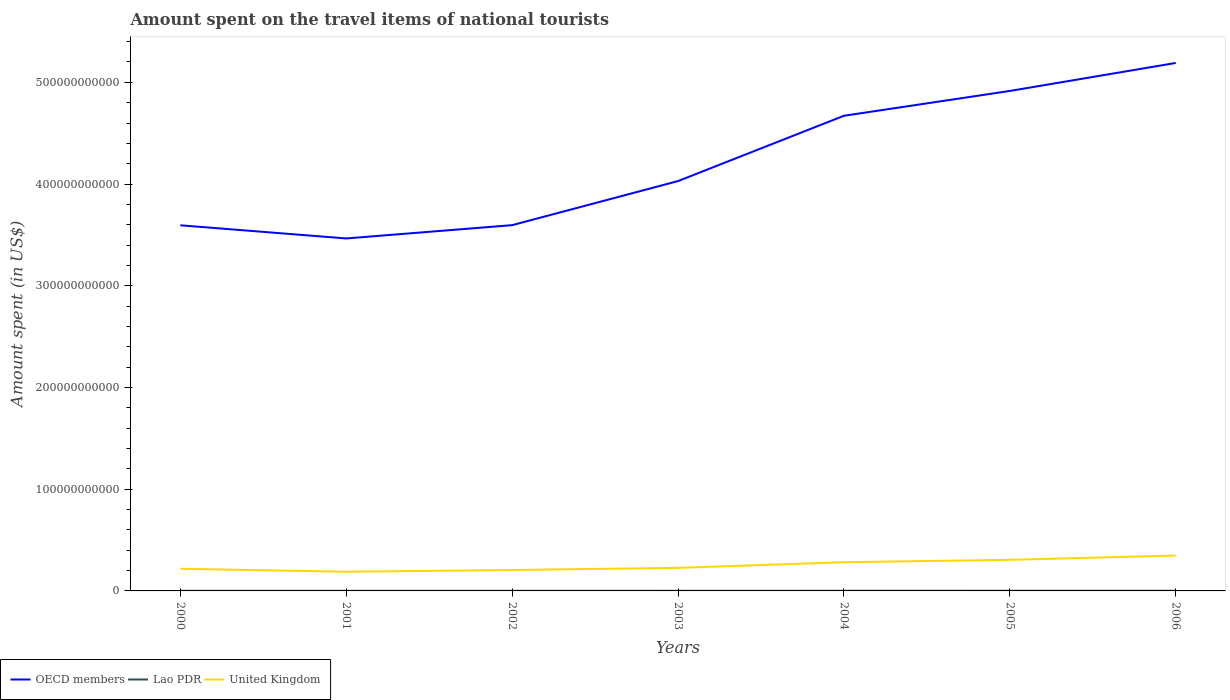Across all years, what is the maximum amount spent on the travel items of national tourists in OECD members?
Keep it short and to the point. 3.47e+11. In which year was the amount spent on the travel items of national tourists in OECD members maximum?
Offer a very short reply. 2001. What is the total amount spent on the travel items of national tourists in Lao PDR in the graph?
Your response must be concise. 7.00e+06. What is the difference between the highest and the second highest amount spent on the travel items of national tourists in Lao PDR?
Provide a succinct answer. 8.40e+07. What is the difference between the highest and the lowest amount spent on the travel items of national tourists in United Kingdom?
Your response must be concise. 3. How many lines are there?
Provide a succinct answer. 3. What is the difference between two consecutive major ticks on the Y-axis?
Keep it short and to the point. 1.00e+11. Does the graph contain any zero values?
Give a very brief answer. No. Does the graph contain grids?
Make the answer very short. No. Where does the legend appear in the graph?
Make the answer very short. Bottom left. How are the legend labels stacked?
Offer a terse response. Horizontal. What is the title of the graph?
Your answer should be very brief. Amount spent on the travel items of national tourists. What is the label or title of the X-axis?
Your response must be concise. Years. What is the label or title of the Y-axis?
Your response must be concise. Amount spent (in US$). What is the Amount spent (in US$) of OECD members in 2000?
Your answer should be compact. 3.59e+11. What is the Amount spent (in US$) of Lao PDR in 2000?
Provide a short and direct response. 1.14e+08. What is the Amount spent (in US$) in United Kingdom in 2000?
Give a very brief answer. 2.18e+1. What is the Amount spent (in US$) of OECD members in 2001?
Your response must be concise. 3.47e+11. What is the Amount spent (in US$) in Lao PDR in 2001?
Offer a very short reply. 1.04e+08. What is the Amount spent (in US$) of United Kingdom in 2001?
Offer a very short reply. 1.89e+1. What is the Amount spent (in US$) in OECD members in 2002?
Keep it short and to the point. 3.60e+11. What is the Amount spent (in US$) in Lao PDR in 2002?
Ensure brevity in your answer.  1.07e+08. What is the Amount spent (in US$) in United Kingdom in 2002?
Keep it short and to the point. 2.05e+1. What is the Amount spent (in US$) in OECD members in 2003?
Offer a terse response. 4.03e+11. What is the Amount spent (in US$) in Lao PDR in 2003?
Make the answer very short. 7.40e+07. What is the Amount spent (in US$) of United Kingdom in 2003?
Ensure brevity in your answer.  2.27e+1. What is the Amount spent (in US$) of OECD members in 2004?
Provide a short and direct response. 4.67e+11. What is the Amount spent (in US$) in Lao PDR in 2004?
Your answer should be compact. 1.19e+08. What is the Amount spent (in US$) in United Kingdom in 2004?
Provide a short and direct response. 2.82e+1. What is the Amount spent (in US$) of OECD members in 2005?
Keep it short and to the point. 4.92e+11. What is the Amount spent (in US$) in Lao PDR in 2005?
Your answer should be very brief. 1.39e+08. What is the Amount spent (in US$) of United Kingdom in 2005?
Offer a terse response. 3.06e+1. What is the Amount spent (in US$) of OECD members in 2006?
Ensure brevity in your answer.  5.19e+11. What is the Amount spent (in US$) of Lao PDR in 2006?
Give a very brief answer. 1.58e+08. What is the Amount spent (in US$) of United Kingdom in 2006?
Offer a very short reply. 3.48e+1. Across all years, what is the maximum Amount spent (in US$) in OECD members?
Your answer should be compact. 5.19e+11. Across all years, what is the maximum Amount spent (in US$) in Lao PDR?
Make the answer very short. 1.58e+08. Across all years, what is the maximum Amount spent (in US$) in United Kingdom?
Your answer should be very brief. 3.48e+1. Across all years, what is the minimum Amount spent (in US$) of OECD members?
Your answer should be very brief. 3.47e+11. Across all years, what is the minimum Amount spent (in US$) of Lao PDR?
Give a very brief answer. 7.40e+07. Across all years, what is the minimum Amount spent (in US$) of United Kingdom?
Offer a terse response. 1.89e+1. What is the total Amount spent (in US$) of OECD members in the graph?
Provide a short and direct response. 2.95e+12. What is the total Amount spent (in US$) in Lao PDR in the graph?
Keep it short and to the point. 8.15e+08. What is the total Amount spent (in US$) of United Kingdom in the graph?
Keep it short and to the point. 1.77e+11. What is the difference between the Amount spent (in US$) of OECD members in 2000 and that in 2001?
Ensure brevity in your answer.  1.29e+1. What is the difference between the Amount spent (in US$) in Lao PDR in 2000 and that in 2001?
Your answer should be compact. 1.00e+07. What is the difference between the Amount spent (in US$) of United Kingdom in 2000 and that in 2001?
Ensure brevity in your answer.  2.90e+09. What is the difference between the Amount spent (in US$) of OECD members in 2000 and that in 2002?
Keep it short and to the point. -1.32e+08. What is the difference between the Amount spent (in US$) of United Kingdom in 2000 and that in 2002?
Keep it short and to the point. 1.22e+09. What is the difference between the Amount spent (in US$) of OECD members in 2000 and that in 2003?
Offer a terse response. -4.35e+1. What is the difference between the Amount spent (in US$) in Lao PDR in 2000 and that in 2003?
Your response must be concise. 4.00e+07. What is the difference between the Amount spent (in US$) of United Kingdom in 2000 and that in 2003?
Your answer should be compact. -8.99e+08. What is the difference between the Amount spent (in US$) of OECD members in 2000 and that in 2004?
Offer a terse response. -1.08e+11. What is the difference between the Amount spent (in US$) in Lao PDR in 2000 and that in 2004?
Give a very brief answer. -5.00e+06. What is the difference between the Amount spent (in US$) of United Kingdom in 2000 and that in 2004?
Give a very brief answer. -6.43e+09. What is the difference between the Amount spent (in US$) in OECD members in 2000 and that in 2005?
Offer a terse response. -1.32e+11. What is the difference between the Amount spent (in US$) in Lao PDR in 2000 and that in 2005?
Offer a very short reply. -2.50e+07. What is the difference between the Amount spent (in US$) in United Kingdom in 2000 and that in 2005?
Your answer should be compact. -8.80e+09. What is the difference between the Amount spent (in US$) in OECD members in 2000 and that in 2006?
Offer a very short reply. -1.60e+11. What is the difference between the Amount spent (in US$) in Lao PDR in 2000 and that in 2006?
Your answer should be compact. -4.40e+07. What is the difference between the Amount spent (in US$) in United Kingdom in 2000 and that in 2006?
Keep it short and to the point. -1.30e+1. What is the difference between the Amount spent (in US$) of OECD members in 2001 and that in 2002?
Provide a succinct answer. -1.31e+1. What is the difference between the Amount spent (in US$) in United Kingdom in 2001 and that in 2002?
Make the answer very short. -1.68e+09. What is the difference between the Amount spent (in US$) in OECD members in 2001 and that in 2003?
Ensure brevity in your answer.  -5.64e+1. What is the difference between the Amount spent (in US$) of Lao PDR in 2001 and that in 2003?
Your response must be concise. 3.00e+07. What is the difference between the Amount spent (in US$) in United Kingdom in 2001 and that in 2003?
Make the answer very short. -3.80e+09. What is the difference between the Amount spent (in US$) of OECD members in 2001 and that in 2004?
Make the answer very short. -1.21e+11. What is the difference between the Amount spent (in US$) in Lao PDR in 2001 and that in 2004?
Provide a short and direct response. -1.50e+07. What is the difference between the Amount spent (in US$) in United Kingdom in 2001 and that in 2004?
Provide a short and direct response. -9.34e+09. What is the difference between the Amount spent (in US$) in OECD members in 2001 and that in 2005?
Give a very brief answer. -1.45e+11. What is the difference between the Amount spent (in US$) in Lao PDR in 2001 and that in 2005?
Your answer should be very brief. -3.50e+07. What is the difference between the Amount spent (in US$) of United Kingdom in 2001 and that in 2005?
Provide a short and direct response. -1.17e+1. What is the difference between the Amount spent (in US$) of OECD members in 2001 and that in 2006?
Your answer should be compact. -1.73e+11. What is the difference between the Amount spent (in US$) of Lao PDR in 2001 and that in 2006?
Keep it short and to the point. -5.40e+07. What is the difference between the Amount spent (in US$) of United Kingdom in 2001 and that in 2006?
Keep it short and to the point. -1.59e+1. What is the difference between the Amount spent (in US$) of OECD members in 2002 and that in 2003?
Offer a very short reply. -4.33e+1. What is the difference between the Amount spent (in US$) of Lao PDR in 2002 and that in 2003?
Make the answer very short. 3.30e+07. What is the difference between the Amount spent (in US$) of United Kingdom in 2002 and that in 2003?
Keep it short and to the point. -2.12e+09. What is the difference between the Amount spent (in US$) in OECD members in 2002 and that in 2004?
Offer a very short reply. -1.08e+11. What is the difference between the Amount spent (in US$) of Lao PDR in 2002 and that in 2004?
Offer a very short reply. -1.20e+07. What is the difference between the Amount spent (in US$) in United Kingdom in 2002 and that in 2004?
Make the answer very short. -7.65e+09. What is the difference between the Amount spent (in US$) in OECD members in 2002 and that in 2005?
Your answer should be very brief. -1.32e+11. What is the difference between the Amount spent (in US$) in Lao PDR in 2002 and that in 2005?
Your answer should be very brief. -3.20e+07. What is the difference between the Amount spent (in US$) in United Kingdom in 2002 and that in 2005?
Offer a very short reply. -1.00e+1. What is the difference between the Amount spent (in US$) of OECD members in 2002 and that in 2006?
Your answer should be compact. -1.59e+11. What is the difference between the Amount spent (in US$) of Lao PDR in 2002 and that in 2006?
Provide a succinct answer. -5.10e+07. What is the difference between the Amount spent (in US$) of United Kingdom in 2002 and that in 2006?
Keep it short and to the point. -1.42e+1. What is the difference between the Amount spent (in US$) of OECD members in 2003 and that in 2004?
Keep it short and to the point. -6.42e+1. What is the difference between the Amount spent (in US$) in Lao PDR in 2003 and that in 2004?
Make the answer very short. -4.50e+07. What is the difference between the Amount spent (in US$) of United Kingdom in 2003 and that in 2004?
Make the answer very short. -5.53e+09. What is the difference between the Amount spent (in US$) in OECD members in 2003 and that in 2005?
Your response must be concise. -8.86e+1. What is the difference between the Amount spent (in US$) of Lao PDR in 2003 and that in 2005?
Offer a very short reply. -6.50e+07. What is the difference between the Amount spent (in US$) in United Kingdom in 2003 and that in 2005?
Your response must be concise. -7.90e+09. What is the difference between the Amount spent (in US$) of OECD members in 2003 and that in 2006?
Provide a short and direct response. -1.16e+11. What is the difference between the Amount spent (in US$) in Lao PDR in 2003 and that in 2006?
Offer a very short reply. -8.40e+07. What is the difference between the Amount spent (in US$) of United Kingdom in 2003 and that in 2006?
Give a very brief answer. -1.21e+1. What is the difference between the Amount spent (in US$) of OECD members in 2004 and that in 2005?
Make the answer very short. -2.44e+1. What is the difference between the Amount spent (in US$) in Lao PDR in 2004 and that in 2005?
Keep it short and to the point. -2.00e+07. What is the difference between the Amount spent (in US$) of United Kingdom in 2004 and that in 2005?
Keep it short and to the point. -2.37e+09. What is the difference between the Amount spent (in US$) of OECD members in 2004 and that in 2006?
Offer a very short reply. -5.19e+1. What is the difference between the Amount spent (in US$) of Lao PDR in 2004 and that in 2006?
Your answer should be compact. -3.90e+07. What is the difference between the Amount spent (in US$) in United Kingdom in 2004 and that in 2006?
Provide a succinct answer. -6.59e+09. What is the difference between the Amount spent (in US$) in OECD members in 2005 and that in 2006?
Offer a terse response. -2.75e+1. What is the difference between the Amount spent (in US$) of Lao PDR in 2005 and that in 2006?
Provide a short and direct response. -1.90e+07. What is the difference between the Amount spent (in US$) in United Kingdom in 2005 and that in 2006?
Offer a very short reply. -4.22e+09. What is the difference between the Amount spent (in US$) of OECD members in 2000 and the Amount spent (in US$) of Lao PDR in 2001?
Offer a terse response. 3.59e+11. What is the difference between the Amount spent (in US$) in OECD members in 2000 and the Amount spent (in US$) in United Kingdom in 2001?
Your answer should be very brief. 3.41e+11. What is the difference between the Amount spent (in US$) of Lao PDR in 2000 and the Amount spent (in US$) of United Kingdom in 2001?
Your answer should be very brief. -1.88e+1. What is the difference between the Amount spent (in US$) in OECD members in 2000 and the Amount spent (in US$) in Lao PDR in 2002?
Keep it short and to the point. 3.59e+11. What is the difference between the Amount spent (in US$) in OECD members in 2000 and the Amount spent (in US$) in United Kingdom in 2002?
Your response must be concise. 3.39e+11. What is the difference between the Amount spent (in US$) in Lao PDR in 2000 and the Amount spent (in US$) in United Kingdom in 2002?
Keep it short and to the point. -2.04e+1. What is the difference between the Amount spent (in US$) of OECD members in 2000 and the Amount spent (in US$) of Lao PDR in 2003?
Provide a short and direct response. 3.59e+11. What is the difference between the Amount spent (in US$) in OECD members in 2000 and the Amount spent (in US$) in United Kingdom in 2003?
Provide a short and direct response. 3.37e+11. What is the difference between the Amount spent (in US$) in Lao PDR in 2000 and the Amount spent (in US$) in United Kingdom in 2003?
Ensure brevity in your answer.  -2.26e+1. What is the difference between the Amount spent (in US$) in OECD members in 2000 and the Amount spent (in US$) in Lao PDR in 2004?
Your response must be concise. 3.59e+11. What is the difference between the Amount spent (in US$) of OECD members in 2000 and the Amount spent (in US$) of United Kingdom in 2004?
Keep it short and to the point. 3.31e+11. What is the difference between the Amount spent (in US$) in Lao PDR in 2000 and the Amount spent (in US$) in United Kingdom in 2004?
Offer a terse response. -2.81e+1. What is the difference between the Amount spent (in US$) of OECD members in 2000 and the Amount spent (in US$) of Lao PDR in 2005?
Offer a very short reply. 3.59e+11. What is the difference between the Amount spent (in US$) of OECD members in 2000 and the Amount spent (in US$) of United Kingdom in 2005?
Your answer should be very brief. 3.29e+11. What is the difference between the Amount spent (in US$) of Lao PDR in 2000 and the Amount spent (in US$) of United Kingdom in 2005?
Your response must be concise. -3.05e+1. What is the difference between the Amount spent (in US$) of OECD members in 2000 and the Amount spent (in US$) of Lao PDR in 2006?
Your answer should be very brief. 3.59e+11. What is the difference between the Amount spent (in US$) in OECD members in 2000 and the Amount spent (in US$) in United Kingdom in 2006?
Make the answer very short. 3.25e+11. What is the difference between the Amount spent (in US$) of Lao PDR in 2000 and the Amount spent (in US$) of United Kingdom in 2006?
Your answer should be compact. -3.47e+1. What is the difference between the Amount spent (in US$) of OECD members in 2001 and the Amount spent (in US$) of Lao PDR in 2002?
Your answer should be very brief. 3.46e+11. What is the difference between the Amount spent (in US$) in OECD members in 2001 and the Amount spent (in US$) in United Kingdom in 2002?
Offer a terse response. 3.26e+11. What is the difference between the Amount spent (in US$) in Lao PDR in 2001 and the Amount spent (in US$) in United Kingdom in 2002?
Provide a succinct answer. -2.04e+1. What is the difference between the Amount spent (in US$) of OECD members in 2001 and the Amount spent (in US$) of Lao PDR in 2003?
Offer a very short reply. 3.46e+11. What is the difference between the Amount spent (in US$) in OECD members in 2001 and the Amount spent (in US$) in United Kingdom in 2003?
Give a very brief answer. 3.24e+11. What is the difference between the Amount spent (in US$) in Lao PDR in 2001 and the Amount spent (in US$) in United Kingdom in 2003?
Provide a short and direct response. -2.26e+1. What is the difference between the Amount spent (in US$) in OECD members in 2001 and the Amount spent (in US$) in Lao PDR in 2004?
Keep it short and to the point. 3.46e+11. What is the difference between the Amount spent (in US$) of OECD members in 2001 and the Amount spent (in US$) of United Kingdom in 2004?
Offer a terse response. 3.18e+11. What is the difference between the Amount spent (in US$) of Lao PDR in 2001 and the Amount spent (in US$) of United Kingdom in 2004?
Offer a very short reply. -2.81e+1. What is the difference between the Amount spent (in US$) in OECD members in 2001 and the Amount spent (in US$) in Lao PDR in 2005?
Your answer should be compact. 3.46e+11. What is the difference between the Amount spent (in US$) in OECD members in 2001 and the Amount spent (in US$) in United Kingdom in 2005?
Give a very brief answer. 3.16e+11. What is the difference between the Amount spent (in US$) of Lao PDR in 2001 and the Amount spent (in US$) of United Kingdom in 2005?
Ensure brevity in your answer.  -3.05e+1. What is the difference between the Amount spent (in US$) in OECD members in 2001 and the Amount spent (in US$) in Lao PDR in 2006?
Provide a short and direct response. 3.46e+11. What is the difference between the Amount spent (in US$) of OECD members in 2001 and the Amount spent (in US$) of United Kingdom in 2006?
Your answer should be compact. 3.12e+11. What is the difference between the Amount spent (in US$) of Lao PDR in 2001 and the Amount spent (in US$) of United Kingdom in 2006?
Your answer should be very brief. -3.47e+1. What is the difference between the Amount spent (in US$) of OECD members in 2002 and the Amount spent (in US$) of Lao PDR in 2003?
Make the answer very short. 3.60e+11. What is the difference between the Amount spent (in US$) of OECD members in 2002 and the Amount spent (in US$) of United Kingdom in 2003?
Provide a succinct answer. 3.37e+11. What is the difference between the Amount spent (in US$) in Lao PDR in 2002 and the Amount spent (in US$) in United Kingdom in 2003?
Provide a short and direct response. -2.26e+1. What is the difference between the Amount spent (in US$) of OECD members in 2002 and the Amount spent (in US$) of Lao PDR in 2004?
Your answer should be compact. 3.59e+11. What is the difference between the Amount spent (in US$) of OECD members in 2002 and the Amount spent (in US$) of United Kingdom in 2004?
Ensure brevity in your answer.  3.31e+11. What is the difference between the Amount spent (in US$) of Lao PDR in 2002 and the Amount spent (in US$) of United Kingdom in 2004?
Your response must be concise. -2.81e+1. What is the difference between the Amount spent (in US$) in OECD members in 2002 and the Amount spent (in US$) in Lao PDR in 2005?
Make the answer very short. 3.59e+11. What is the difference between the Amount spent (in US$) in OECD members in 2002 and the Amount spent (in US$) in United Kingdom in 2005?
Your answer should be compact. 3.29e+11. What is the difference between the Amount spent (in US$) in Lao PDR in 2002 and the Amount spent (in US$) in United Kingdom in 2005?
Ensure brevity in your answer.  -3.05e+1. What is the difference between the Amount spent (in US$) of OECD members in 2002 and the Amount spent (in US$) of Lao PDR in 2006?
Keep it short and to the point. 3.59e+11. What is the difference between the Amount spent (in US$) of OECD members in 2002 and the Amount spent (in US$) of United Kingdom in 2006?
Offer a terse response. 3.25e+11. What is the difference between the Amount spent (in US$) of Lao PDR in 2002 and the Amount spent (in US$) of United Kingdom in 2006?
Your answer should be very brief. -3.47e+1. What is the difference between the Amount spent (in US$) in OECD members in 2003 and the Amount spent (in US$) in Lao PDR in 2004?
Ensure brevity in your answer.  4.03e+11. What is the difference between the Amount spent (in US$) in OECD members in 2003 and the Amount spent (in US$) in United Kingdom in 2004?
Provide a succinct answer. 3.75e+11. What is the difference between the Amount spent (in US$) in Lao PDR in 2003 and the Amount spent (in US$) in United Kingdom in 2004?
Provide a short and direct response. -2.81e+1. What is the difference between the Amount spent (in US$) of OECD members in 2003 and the Amount spent (in US$) of Lao PDR in 2005?
Offer a terse response. 4.03e+11. What is the difference between the Amount spent (in US$) of OECD members in 2003 and the Amount spent (in US$) of United Kingdom in 2005?
Ensure brevity in your answer.  3.72e+11. What is the difference between the Amount spent (in US$) of Lao PDR in 2003 and the Amount spent (in US$) of United Kingdom in 2005?
Your answer should be very brief. -3.05e+1. What is the difference between the Amount spent (in US$) of OECD members in 2003 and the Amount spent (in US$) of Lao PDR in 2006?
Offer a terse response. 4.03e+11. What is the difference between the Amount spent (in US$) in OECD members in 2003 and the Amount spent (in US$) in United Kingdom in 2006?
Your answer should be very brief. 3.68e+11. What is the difference between the Amount spent (in US$) in Lao PDR in 2003 and the Amount spent (in US$) in United Kingdom in 2006?
Your answer should be compact. -3.47e+1. What is the difference between the Amount spent (in US$) of OECD members in 2004 and the Amount spent (in US$) of Lao PDR in 2005?
Your answer should be very brief. 4.67e+11. What is the difference between the Amount spent (in US$) in OECD members in 2004 and the Amount spent (in US$) in United Kingdom in 2005?
Ensure brevity in your answer.  4.37e+11. What is the difference between the Amount spent (in US$) of Lao PDR in 2004 and the Amount spent (in US$) of United Kingdom in 2005?
Offer a terse response. -3.05e+1. What is the difference between the Amount spent (in US$) in OECD members in 2004 and the Amount spent (in US$) in Lao PDR in 2006?
Offer a very short reply. 4.67e+11. What is the difference between the Amount spent (in US$) in OECD members in 2004 and the Amount spent (in US$) in United Kingdom in 2006?
Provide a succinct answer. 4.32e+11. What is the difference between the Amount spent (in US$) of Lao PDR in 2004 and the Amount spent (in US$) of United Kingdom in 2006?
Offer a terse response. -3.47e+1. What is the difference between the Amount spent (in US$) of OECD members in 2005 and the Amount spent (in US$) of Lao PDR in 2006?
Provide a short and direct response. 4.91e+11. What is the difference between the Amount spent (in US$) of OECD members in 2005 and the Amount spent (in US$) of United Kingdom in 2006?
Offer a terse response. 4.57e+11. What is the difference between the Amount spent (in US$) of Lao PDR in 2005 and the Amount spent (in US$) of United Kingdom in 2006?
Your answer should be very brief. -3.47e+1. What is the average Amount spent (in US$) of OECD members per year?
Your answer should be compact. 4.21e+11. What is the average Amount spent (in US$) in Lao PDR per year?
Give a very brief answer. 1.16e+08. What is the average Amount spent (in US$) in United Kingdom per year?
Your answer should be very brief. 2.53e+1. In the year 2000, what is the difference between the Amount spent (in US$) of OECD members and Amount spent (in US$) of Lao PDR?
Your answer should be very brief. 3.59e+11. In the year 2000, what is the difference between the Amount spent (in US$) in OECD members and Amount spent (in US$) in United Kingdom?
Your response must be concise. 3.38e+11. In the year 2000, what is the difference between the Amount spent (in US$) of Lao PDR and Amount spent (in US$) of United Kingdom?
Provide a short and direct response. -2.17e+1. In the year 2001, what is the difference between the Amount spent (in US$) in OECD members and Amount spent (in US$) in Lao PDR?
Make the answer very short. 3.46e+11. In the year 2001, what is the difference between the Amount spent (in US$) of OECD members and Amount spent (in US$) of United Kingdom?
Keep it short and to the point. 3.28e+11. In the year 2001, what is the difference between the Amount spent (in US$) in Lao PDR and Amount spent (in US$) in United Kingdom?
Ensure brevity in your answer.  -1.88e+1. In the year 2002, what is the difference between the Amount spent (in US$) in OECD members and Amount spent (in US$) in Lao PDR?
Provide a short and direct response. 3.59e+11. In the year 2002, what is the difference between the Amount spent (in US$) in OECD members and Amount spent (in US$) in United Kingdom?
Your answer should be compact. 3.39e+11. In the year 2002, what is the difference between the Amount spent (in US$) of Lao PDR and Amount spent (in US$) of United Kingdom?
Give a very brief answer. -2.04e+1. In the year 2003, what is the difference between the Amount spent (in US$) of OECD members and Amount spent (in US$) of Lao PDR?
Ensure brevity in your answer.  4.03e+11. In the year 2003, what is the difference between the Amount spent (in US$) in OECD members and Amount spent (in US$) in United Kingdom?
Make the answer very short. 3.80e+11. In the year 2003, what is the difference between the Amount spent (in US$) in Lao PDR and Amount spent (in US$) in United Kingdom?
Give a very brief answer. -2.26e+1. In the year 2004, what is the difference between the Amount spent (in US$) of OECD members and Amount spent (in US$) of Lao PDR?
Give a very brief answer. 4.67e+11. In the year 2004, what is the difference between the Amount spent (in US$) of OECD members and Amount spent (in US$) of United Kingdom?
Provide a succinct answer. 4.39e+11. In the year 2004, what is the difference between the Amount spent (in US$) in Lao PDR and Amount spent (in US$) in United Kingdom?
Provide a succinct answer. -2.81e+1. In the year 2005, what is the difference between the Amount spent (in US$) of OECD members and Amount spent (in US$) of Lao PDR?
Ensure brevity in your answer.  4.91e+11. In the year 2005, what is the difference between the Amount spent (in US$) in OECD members and Amount spent (in US$) in United Kingdom?
Offer a very short reply. 4.61e+11. In the year 2005, what is the difference between the Amount spent (in US$) of Lao PDR and Amount spent (in US$) of United Kingdom?
Make the answer very short. -3.04e+1. In the year 2006, what is the difference between the Amount spent (in US$) of OECD members and Amount spent (in US$) of Lao PDR?
Your answer should be compact. 5.19e+11. In the year 2006, what is the difference between the Amount spent (in US$) in OECD members and Amount spent (in US$) in United Kingdom?
Provide a short and direct response. 4.84e+11. In the year 2006, what is the difference between the Amount spent (in US$) of Lao PDR and Amount spent (in US$) of United Kingdom?
Make the answer very short. -3.46e+1. What is the ratio of the Amount spent (in US$) in OECD members in 2000 to that in 2001?
Make the answer very short. 1.04. What is the ratio of the Amount spent (in US$) in Lao PDR in 2000 to that in 2001?
Your answer should be compact. 1.1. What is the ratio of the Amount spent (in US$) of United Kingdom in 2000 to that in 2001?
Make the answer very short. 1.15. What is the ratio of the Amount spent (in US$) of Lao PDR in 2000 to that in 2002?
Provide a short and direct response. 1.07. What is the ratio of the Amount spent (in US$) in United Kingdom in 2000 to that in 2002?
Offer a terse response. 1.06. What is the ratio of the Amount spent (in US$) in OECD members in 2000 to that in 2003?
Your answer should be very brief. 0.89. What is the ratio of the Amount spent (in US$) in Lao PDR in 2000 to that in 2003?
Give a very brief answer. 1.54. What is the ratio of the Amount spent (in US$) in United Kingdom in 2000 to that in 2003?
Provide a short and direct response. 0.96. What is the ratio of the Amount spent (in US$) in OECD members in 2000 to that in 2004?
Give a very brief answer. 0.77. What is the ratio of the Amount spent (in US$) in Lao PDR in 2000 to that in 2004?
Offer a very short reply. 0.96. What is the ratio of the Amount spent (in US$) in United Kingdom in 2000 to that in 2004?
Provide a short and direct response. 0.77. What is the ratio of the Amount spent (in US$) of OECD members in 2000 to that in 2005?
Make the answer very short. 0.73. What is the ratio of the Amount spent (in US$) of Lao PDR in 2000 to that in 2005?
Your response must be concise. 0.82. What is the ratio of the Amount spent (in US$) in United Kingdom in 2000 to that in 2005?
Your response must be concise. 0.71. What is the ratio of the Amount spent (in US$) of OECD members in 2000 to that in 2006?
Make the answer very short. 0.69. What is the ratio of the Amount spent (in US$) of Lao PDR in 2000 to that in 2006?
Provide a short and direct response. 0.72. What is the ratio of the Amount spent (in US$) of United Kingdom in 2000 to that in 2006?
Provide a succinct answer. 0.63. What is the ratio of the Amount spent (in US$) of OECD members in 2001 to that in 2002?
Your response must be concise. 0.96. What is the ratio of the Amount spent (in US$) in United Kingdom in 2001 to that in 2002?
Provide a short and direct response. 0.92. What is the ratio of the Amount spent (in US$) in OECD members in 2001 to that in 2003?
Keep it short and to the point. 0.86. What is the ratio of the Amount spent (in US$) of Lao PDR in 2001 to that in 2003?
Your answer should be compact. 1.41. What is the ratio of the Amount spent (in US$) in United Kingdom in 2001 to that in 2003?
Provide a succinct answer. 0.83. What is the ratio of the Amount spent (in US$) of OECD members in 2001 to that in 2004?
Your answer should be compact. 0.74. What is the ratio of the Amount spent (in US$) in Lao PDR in 2001 to that in 2004?
Your response must be concise. 0.87. What is the ratio of the Amount spent (in US$) of United Kingdom in 2001 to that in 2004?
Offer a terse response. 0.67. What is the ratio of the Amount spent (in US$) of OECD members in 2001 to that in 2005?
Provide a short and direct response. 0.7. What is the ratio of the Amount spent (in US$) of Lao PDR in 2001 to that in 2005?
Ensure brevity in your answer.  0.75. What is the ratio of the Amount spent (in US$) in United Kingdom in 2001 to that in 2005?
Offer a very short reply. 0.62. What is the ratio of the Amount spent (in US$) in OECD members in 2001 to that in 2006?
Give a very brief answer. 0.67. What is the ratio of the Amount spent (in US$) in Lao PDR in 2001 to that in 2006?
Offer a very short reply. 0.66. What is the ratio of the Amount spent (in US$) of United Kingdom in 2001 to that in 2006?
Your answer should be compact. 0.54. What is the ratio of the Amount spent (in US$) in OECD members in 2002 to that in 2003?
Your response must be concise. 0.89. What is the ratio of the Amount spent (in US$) in Lao PDR in 2002 to that in 2003?
Keep it short and to the point. 1.45. What is the ratio of the Amount spent (in US$) in United Kingdom in 2002 to that in 2003?
Make the answer very short. 0.91. What is the ratio of the Amount spent (in US$) of OECD members in 2002 to that in 2004?
Your answer should be very brief. 0.77. What is the ratio of the Amount spent (in US$) in Lao PDR in 2002 to that in 2004?
Provide a succinct answer. 0.9. What is the ratio of the Amount spent (in US$) of United Kingdom in 2002 to that in 2004?
Ensure brevity in your answer.  0.73. What is the ratio of the Amount spent (in US$) of OECD members in 2002 to that in 2005?
Your answer should be very brief. 0.73. What is the ratio of the Amount spent (in US$) of Lao PDR in 2002 to that in 2005?
Your answer should be compact. 0.77. What is the ratio of the Amount spent (in US$) of United Kingdom in 2002 to that in 2005?
Provide a short and direct response. 0.67. What is the ratio of the Amount spent (in US$) of OECD members in 2002 to that in 2006?
Your response must be concise. 0.69. What is the ratio of the Amount spent (in US$) in Lao PDR in 2002 to that in 2006?
Provide a succinct answer. 0.68. What is the ratio of the Amount spent (in US$) in United Kingdom in 2002 to that in 2006?
Offer a terse response. 0.59. What is the ratio of the Amount spent (in US$) in OECD members in 2003 to that in 2004?
Provide a short and direct response. 0.86. What is the ratio of the Amount spent (in US$) in Lao PDR in 2003 to that in 2004?
Your answer should be compact. 0.62. What is the ratio of the Amount spent (in US$) of United Kingdom in 2003 to that in 2004?
Your answer should be very brief. 0.8. What is the ratio of the Amount spent (in US$) in OECD members in 2003 to that in 2005?
Your answer should be compact. 0.82. What is the ratio of the Amount spent (in US$) in Lao PDR in 2003 to that in 2005?
Keep it short and to the point. 0.53. What is the ratio of the Amount spent (in US$) of United Kingdom in 2003 to that in 2005?
Offer a very short reply. 0.74. What is the ratio of the Amount spent (in US$) in OECD members in 2003 to that in 2006?
Offer a terse response. 0.78. What is the ratio of the Amount spent (in US$) of Lao PDR in 2003 to that in 2006?
Your answer should be compact. 0.47. What is the ratio of the Amount spent (in US$) of United Kingdom in 2003 to that in 2006?
Give a very brief answer. 0.65. What is the ratio of the Amount spent (in US$) of OECD members in 2004 to that in 2005?
Your response must be concise. 0.95. What is the ratio of the Amount spent (in US$) in Lao PDR in 2004 to that in 2005?
Provide a succinct answer. 0.86. What is the ratio of the Amount spent (in US$) of United Kingdom in 2004 to that in 2005?
Provide a succinct answer. 0.92. What is the ratio of the Amount spent (in US$) of OECD members in 2004 to that in 2006?
Your answer should be very brief. 0.9. What is the ratio of the Amount spent (in US$) in Lao PDR in 2004 to that in 2006?
Ensure brevity in your answer.  0.75. What is the ratio of the Amount spent (in US$) of United Kingdom in 2004 to that in 2006?
Your answer should be compact. 0.81. What is the ratio of the Amount spent (in US$) of OECD members in 2005 to that in 2006?
Ensure brevity in your answer.  0.95. What is the ratio of the Amount spent (in US$) in Lao PDR in 2005 to that in 2006?
Offer a very short reply. 0.88. What is the ratio of the Amount spent (in US$) of United Kingdom in 2005 to that in 2006?
Make the answer very short. 0.88. What is the difference between the highest and the second highest Amount spent (in US$) of OECD members?
Provide a succinct answer. 2.75e+1. What is the difference between the highest and the second highest Amount spent (in US$) in Lao PDR?
Offer a terse response. 1.90e+07. What is the difference between the highest and the second highest Amount spent (in US$) of United Kingdom?
Keep it short and to the point. 4.22e+09. What is the difference between the highest and the lowest Amount spent (in US$) in OECD members?
Provide a short and direct response. 1.73e+11. What is the difference between the highest and the lowest Amount spent (in US$) of Lao PDR?
Make the answer very short. 8.40e+07. What is the difference between the highest and the lowest Amount spent (in US$) in United Kingdom?
Make the answer very short. 1.59e+1. 